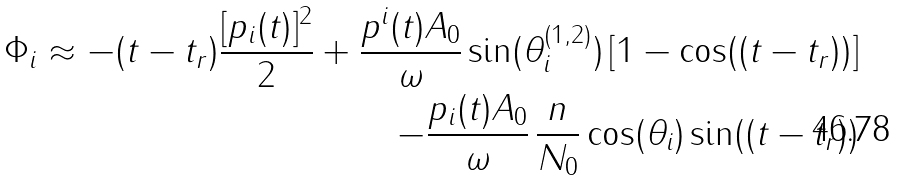<formula> <loc_0><loc_0><loc_500><loc_500>\Phi _ { i } \approx - ( t - t _ { r } ) \frac { [ p _ { i } ( t ) ] ^ { 2 } } { 2 } + \frac { p ^ { i } ( t ) A _ { 0 } } { \omega } \sin ( \theta _ { i } ^ { ( 1 , 2 ) } ) \left [ 1 - \cos ( ( t - t _ { r } ) ) \right ] \\ - \frac { p _ { i } ( t ) A _ { 0 } } { \omega } \, \frac { n } { N _ { 0 } } \cos ( \theta _ { i } ) \sin ( ( t - t _ { r } ) )</formula> 